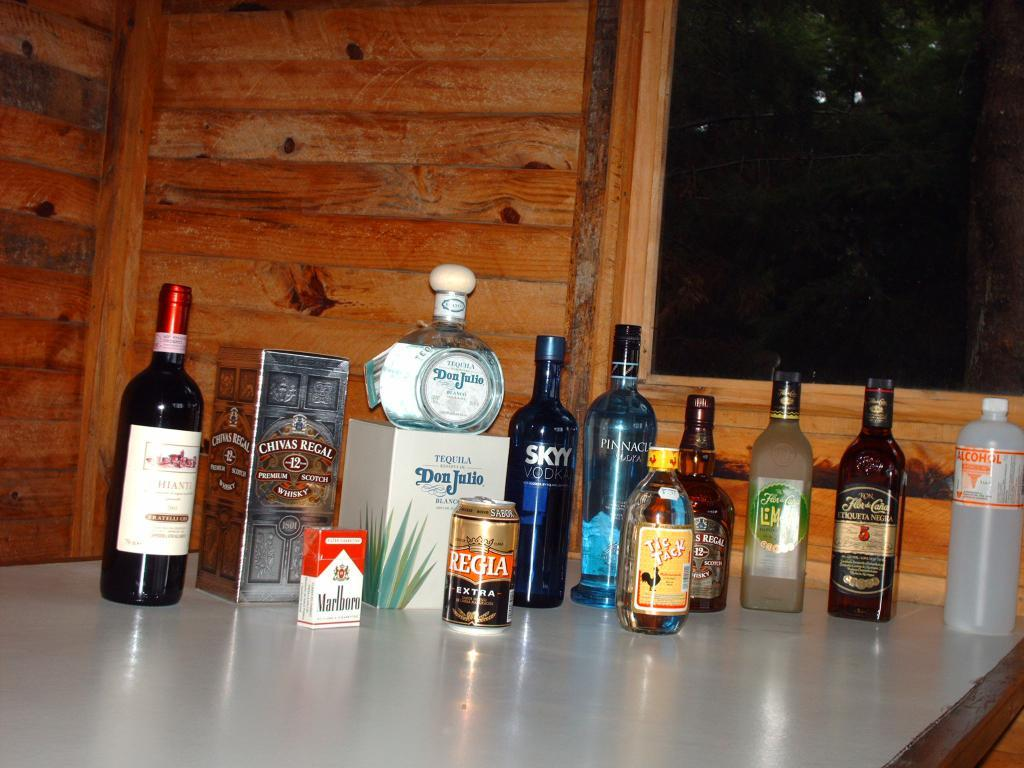Provide a one-sentence caption for the provided image. Several bottles and cans lined up on a table with a pack of Marlboro cigarettes. 